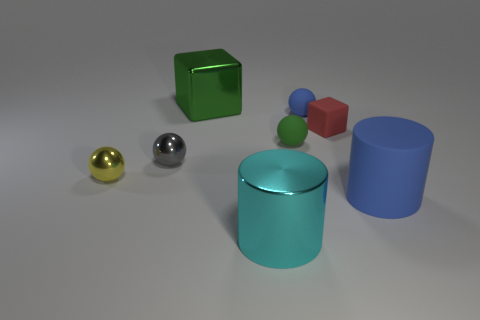There is a small blue rubber object; is it the same shape as the blue object in front of the gray shiny ball?
Offer a very short reply. No. What size is the cube that is left of the big shiny cylinder?
Your answer should be compact. Large. What material is the small block?
Ensure brevity in your answer.  Rubber. There is a large metal object that is right of the metallic cube; is its shape the same as the large green metal object?
Offer a very short reply. No. There is a ball that is the same color as the large matte cylinder; what is its size?
Provide a succinct answer. Small. Is there a red rubber cube of the same size as the blue rubber ball?
Your answer should be compact. Yes. There is a green thing in front of the block behind the red rubber block; is there a blue matte sphere that is to the left of it?
Your answer should be compact. No. There is a matte block; is it the same color as the shiny sphere behind the yellow ball?
Your answer should be compact. No. There is a big cylinder in front of the large cylinder to the right of the cylinder that is in front of the large blue rubber object; what is its material?
Offer a very short reply. Metal. There is a large object on the left side of the cyan metallic object; what is its shape?
Ensure brevity in your answer.  Cube. 